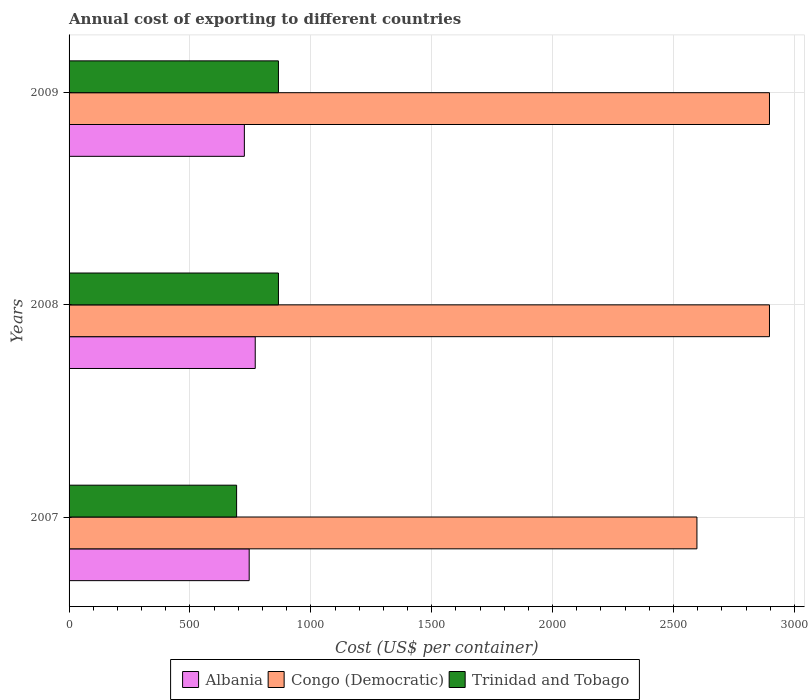Are the number of bars on each tick of the Y-axis equal?
Ensure brevity in your answer.  Yes. How many bars are there on the 1st tick from the top?
Make the answer very short. 3. What is the total annual cost of exporting in Albania in 2007?
Provide a short and direct response. 745. Across all years, what is the maximum total annual cost of exporting in Trinidad and Tobago?
Offer a terse response. 866. Across all years, what is the minimum total annual cost of exporting in Trinidad and Tobago?
Your response must be concise. 693. In which year was the total annual cost of exporting in Albania minimum?
Your answer should be very brief. 2009. What is the total total annual cost of exporting in Trinidad and Tobago in the graph?
Make the answer very short. 2425. What is the difference between the total annual cost of exporting in Albania in 2007 and that in 2008?
Your answer should be compact. -25. What is the difference between the total annual cost of exporting in Trinidad and Tobago in 2009 and the total annual cost of exporting in Congo (Democratic) in 2007?
Your answer should be very brief. -1731. What is the average total annual cost of exporting in Congo (Democratic) per year?
Your answer should be very brief. 2797. In the year 2008, what is the difference between the total annual cost of exporting in Albania and total annual cost of exporting in Trinidad and Tobago?
Ensure brevity in your answer.  -96. What is the ratio of the total annual cost of exporting in Albania in 2008 to that in 2009?
Keep it short and to the point. 1.06. Is the difference between the total annual cost of exporting in Albania in 2008 and 2009 greater than the difference between the total annual cost of exporting in Trinidad and Tobago in 2008 and 2009?
Provide a short and direct response. Yes. What is the difference between the highest and the second highest total annual cost of exporting in Congo (Democratic)?
Your answer should be compact. 0. What is the difference between the highest and the lowest total annual cost of exporting in Congo (Democratic)?
Offer a terse response. 300. In how many years, is the total annual cost of exporting in Congo (Democratic) greater than the average total annual cost of exporting in Congo (Democratic) taken over all years?
Keep it short and to the point. 2. Is the sum of the total annual cost of exporting in Congo (Democratic) in 2007 and 2008 greater than the maximum total annual cost of exporting in Albania across all years?
Ensure brevity in your answer.  Yes. What does the 3rd bar from the top in 2008 represents?
Provide a succinct answer. Albania. What does the 3rd bar from the bottom in 2009 represents?
Your answer should be very brief. Trinidad and Tobago. How many bars are there?
Offer a very short reply. 9. Are all the bars in the graph horizontal?
Offer a terse response. Yes. What is the difference between two consecutive major ticks on the X-axis?
Your answer should be compact. 500. Are the values on the major ticks of X-axis written in scientific E-notation?
Provide a short and direct response. No. Does the graph contain any zero values?
Your answer should be very brief. No. How many legend labels are there?
Ensure brevity in your answer.  3. What is the title of the graph?
Offer a very short reply. Annual cost of exporting to different countries. What is the label or title of the X-axis?
Keep it short and to the point. Cost (US$ per container). What is the label or title of the Y-axis?
Offer a very short reply. Years. What is the Cost (US$ per container) of Albania in 2007?
Ensure brevity in your answer.  745. What is the Cost (US$ per container) in Congo (Democratic) in 2007?
Make the answer very short. 2597. What is the Cost (US$ per container) of Trinidad and Tobago in 2007?
Provide a short and direct response. 693. What is the Cost (US$ per container) in Albania in 2008?
Keep it short and to the point. 770. What is the Cost (US$ per container) of Congo (Democratic) in 2008?
Provide a succinct answer. 2897. What is the Cost (US$ per container) of Trinidad and Tobago in 2008?
Give a very brief answer. 866. What is the Cost (US$ per container) of Albania in 2009?
Ensure brevity in your answer.  725. What is the Cost (US$ per container) in Congo (Democratic) in 2009?
Keep it short and to the point. 2897. What is the Cost (US$ per container) of Trinidad and Tobago in 2009?
Offer a very short reply. 866. Across all years, what is the maximum Cost (US$ per container) of Albania?
Your answer should be very brief. 770. Across all years, what is the maximum Cost (US$ per container) of Congo (Democratic)?
Keep it short and to the point. 2897. Across all years, what is the maximum Cost (US$ per container) of Trinidad and Tobago?
Your response must be concise. 866. Across all years, what is the minimum Cost (US$ per container) in Albania?
Keep it short and to the point. 725. Across all years, what is the minimum Cost (US$ per container) in Congo (Democratic)?
Your response must be concise. 2597. Across all years, what is the minimum Cost (US$ per container) in Trinidad and Tobago?
Give a very brief answer. 693. What is the total Cost (US$ per container) of Albania in the graph?
Keep it short and to the point. 2240. What is the total Cost (US$ per container) in Congo (Democratic) in the graph?
Make the answer very short. 8391. What is the total Cost (US$ per container) in Trinidad and Tobago in the graph?
Provide a succinct answer. 2425. What is the difference between the Cost (US$ per container) of Albania in 2007 and that in 2008?
Offer a terse response. -25. What is the difference between the Cost (US$ per container) in Congo (Democratic) in 2007 and that in 2008?
Your response must be concise. -300. What is the difference between the Cost (US$ per container) of Trinidad and Tobago in 2007 and that in 2008?
Offer a very short reply. -173. What is the difference between the Cost (US$ per container) of Albania in 2007 and that in 2009?
Your answer should be compact. 20. What is the difference between the Cost (US$ per container) in Congo (Democratic) in 2007 and that in 2009?
Keep it short and to the point. -300. What is the difference between the Cost (US$ per container) of Trinidad and Tobago in 2007 and that in 2009?
Make the answer very short. -173. What is the difference between the Cost (US$ per container) in Congo (Democratic) in 2008 and that in 2009?
Keep it short and to the point. 0. What is the difference between the Cost (US$ per container) of Albania in 2007 and the Cost (US$ per container) of Congo (Democratic) in 2008?
Give a very brief answer. -2152. What is the difference between the Cost (US$ per container) of Albania in 2007 and the Cost (US$ per container) of Trinidad and Tobago in 2008?
Provide a succinct answer. -121. What is the difference between the Cost (US$ per container) of Congo (Democratic) in 2007 and the Cost (US$ per container) of Trinidad and Tobago in 2008?
Your answer should be compact. 1731. What is the difference between the Cost (US$ per container) of Albania in 2007 and the Cost (US$ per container) of Congo (Democratic) in 2009?
Your answer should be very brief. -2152. What is the difference between the Cost (US$ per container) in Albania in 2007 and the Cost (US$ per container) in Trinidad and Tobago in 2009?
Your answer should be compact. -121. What is the difference between the Cost (US$ per container) in Congo (Democratic) in 2007 and the Cost (US$ per container) in Trinidad and Tobago in 2009?
Your answer should be very brief. 1731. What is the difference between the Cost (US$ per container) in Albania in 2008 and the Cost (US$ per container) in Congo (Democratic) in 2009?
Your response must be concise. -2127. What is the difference between the Cost (US$ per container) of Albania in 2008 and the Cost (US$ per container) of Trinidad and Tobago in 2009?
Provide a succinct answer. -96. What is the difference between the Cost (US$ per container) in Congo (Democratic) in 2008 and the Cost (US$ per container) in Trinidad and Tobago in 2009?
Keep it short and to the point. 2031. What is the average Cost (US$ per container) in Albania per year?
Offer a very short reply. 746.67. What is the average Cost (US$ per container) of Congo (Democratic) per year?
Offer a very short reply. 2797. What is the average Cost (US$ per container) of Trinidad and Tobago per year?
Your response must be concise. 808.33. In the year 2007, what is the difference between the Cost (US$ per container) in Albania and Cost (US$ per container) in Congo (Democratic)?
Offer a terse response. -1852. In the year 2007, what is the difference between the Cost (US$ per container) of Albania and Cost (US$ per container) of Trinidad and Tobago?
Give a very brief answer. 52. In the year 2007, what is the difference between the Cost (US$ per container) in Congo (Democratic) and Cost (US$ per container) in Trinidad and Tobago?
Offer a very short reply. 1904. In the year 2008, what is the difference between the Cost (US$ per container) in Albania and Cost (US$ per container) in Congo (Democratic)?
Make the answer very short. -2127. In the year 2008, what is the difference between the Cost (US$ per container) of Albania and Cost (US$ per container) of Trinidad and Tobago?
Make the answer very short. -96. In the year 2008, what is the difference between the Cost (US$ per container) in Congo (Democratic) and Cost (US$ per container) in Trinidad and Tobago?
Your response must be concise. 2031. In the year 2009, what is the difference between the Cost (US$ per container) of Albania and Cost (US$ per container) of Congo (Democratic)?
Offer a terse response. -2172. In the year 2009, what is the difference between the Cost (US$ per container) of Albania and Cost (US$ per container) of Trinidad and Tobago?
Give a very brief answer. -141. In the year 2009, what is the difference between the Cost (US$ per container) of Congo (Democratic) and Cost (US$ per container) of Trinidad and Tobago?
Your answer should be very brief. 2031. What is the ratio of the Cost (US$ per container) in Albania in 2007 to that in 2008?
Your answer should be very brief. 0.97. What is the ratio of the Cost (US$ per container) in Congo (Democratic) in 2007 to that in 2008?
Your answer should be compact. 0.9. What is the ratio of the Cost (US$ per container) in Trinidad and Tobago in 2007 to that in 2008?
Your answer should be compact. 0.8. What is the ratio of the Cost (US$ per container) of Albania in 2007 to that in 2009?
Provide a succinct answer. 1.03. What is the ratio of the Cost (US$ per container) in Congo (Democratic) in 2007 to that in 2009?
Your answer should be compact. 0.9. What is the ratio of the Cost (US$ per container) of Trinidad and Tobago in 2007 to that in 2009?
Your answer should be compact. 0.8. What is the ratio of the Cost (US$ per container) in Albania in 2008 to that in 2009?
Make the answer very short. 1.06. What is the ratio of the Cost (US$ per container) in Trinidad and Tobago in 2008 to that in 2009?
Keep it short and to the point. 1. What is the difference between the highest and the lowest Cost (US$ per container) in Albania?
Offer a terse response. 45. What is the difference between the highest and the lowest Cost (US$ per container) in Congo (Democratic)?
Offer a very short reply. 300. What is the difference between the highest and the lowest Cost (US$ per container) of Trinidad and Tobago?
Provide a short and direct response. 173. 